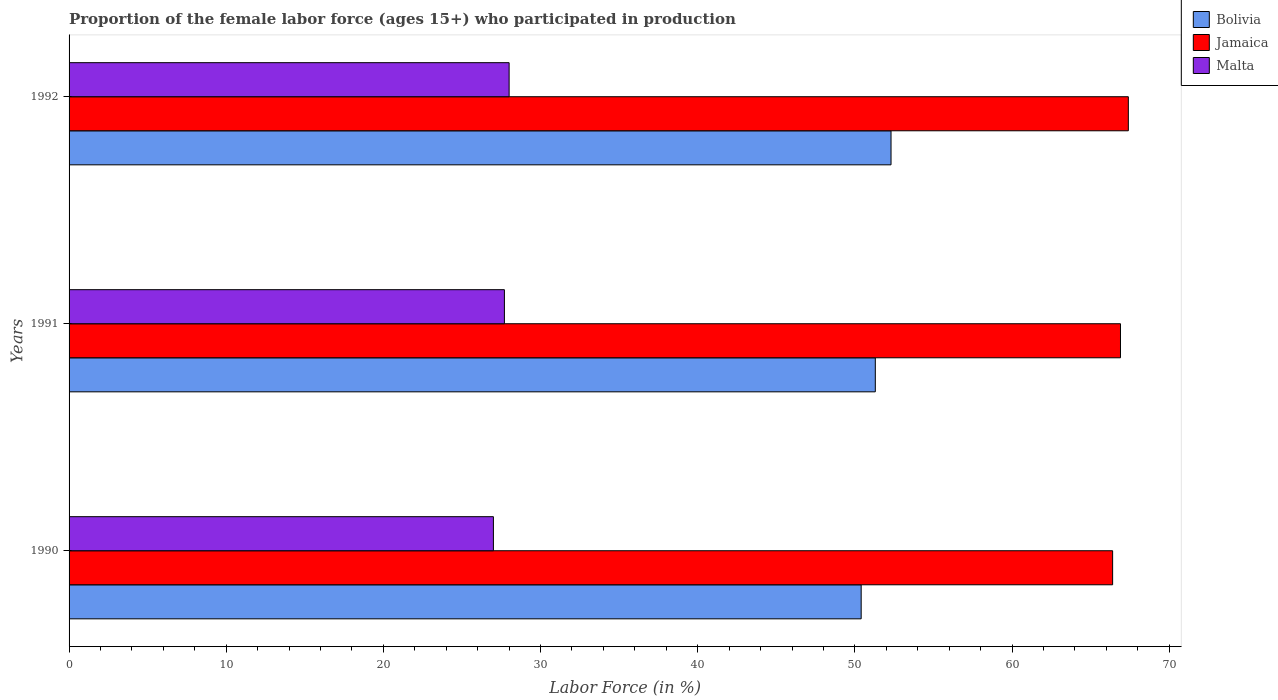How many different coloured bars are there?
Provide a succinct answer. 3. Are the number of bars on each tick of the Y-axis equal?
Offer a terse response. Yes. What is the proportion of the female labor force who participated in production in Jamaica in 1991?
Your answer should be compact. 66.9. Across all years, what is the maximum proportion of the female labor force who participated in production in Jamaica?
Your answer should be very brief. 67.4. Across all years, what is the minimum proportion of the female labor force who participated in production in Jamaica?
Provide a short and direct response. 66.4. In which year was the proportion of the female labor force who participated in production in Jamaica maximum?
Your response must be concise. 1992. What is the total proportion of the female labor force who participated in production in Bolivia in the graph?
Your response must be concise. 154. What is the difference between the proportion of the female labor force who participated in production in Bolivia in 1992 and the proportion of the female labor force who participated in production in Jamaica in 1991?
Offer a very short reply. -14.6. What is the average proportion of the female labor force who participated in production in Malta per year?
Make the answer very short. 27.57. In the year 1990, what is the difference between the proportion of the female labor force who participated in production in Bolivia and proportion of the female labor force who participated in production in Malta?
Offer a terse response. 23.4. In how many years, is the proportion of the female labor force who participated in production in Malta greater than 2 %?
Provide a short and direct response. 3. What is the ratio of the proportion of the female labor force who participated in production in Malta in 1990 to that in 1992?
Your response must be concise. 0.96. Is the proportion of the female labor force who participated in production in Malta in 1990 less than that in 1992?
Offer a terse response. Yes. What is the difference between the highest and the second highest proportion of the female labor force who participated in production in Malta?
Give a very brief answer. 0.3. What is the difference between the highest and the lowest proportion of the female labor force who participated in production in Bolivia?
Your answer should be very brief. 1.9. In how many years, is the proportion of the female labor force who participated in production in Malta greater than the average proportion of the female labor force who participated in production in Malta taken over all years?
Keep it short and to the point. 2. Is the sum of the proportion of the female labor force who participated in production in Bolivia in 1990 and 1992 greater than the maximum proportion of the female labor force who participated in production in Malta across all years?
Ensure brevity in your answer.  Yes. What does the 2nd bar from the top in 1992 represents?
Your response must be concise. Jamaica. What does the 2nd bar from the bottom in 1992 represents?
Ensure brevity in your answer.  Jamaica. Is it the case that in every year, the sum of the proportion of the female labor force who participated in production in Bolivia and proportion of the female labor force who participated in production in Jamaica is greater than the proportion of the female labor force who participated in production in Malta?
Make the answer very short. Yes. How many bars are there?
Ensure brevity in your answer.  9. Are all the bars in the graph horizontal?
Keep it short and to the point. Yes. What is the difference between two consecutive major ticks on the X-axis?
Your response must be concise. 10. Are the values on the major ticks of X-axis written in scientific E-notation?
Provide a succinct answer. No. Does the graph contain any zero values?
Your answer should be very brief. No. Does the graph contain grids?
Your answer should be very brief. No. How many legend labels are there?
Your response must be concise. 3. What is the title of the graph?
Your answer should be very brief. Proportion of the female labor force (ages 15+) who participated in production. What is the Labor Force (in %) in Bolivia in 1990?
Ensure brevity in your answer.  50.4. What is the Labor Force (in %) in Jamaica in 1990?
Provide a succinct answer. 66.4. What is the Labor Force (in %) in Bolivia in 1991?
Your answer should be very brief. 51.3. What is the Labor Force (in %) in Jamaica in 1991?
Offer a terse response. 66.9. What is the Labor Force (in %) in Malta in 1991?
Provide a succinct answer. 27.7. What is the Labor Force (in %) in Bolivia in 1992?
Keep it short and to the point. 52.3. What is the Labor Force (in %) in Jamaica in 1992?
Keep it short and to the point. 67.4. Across all years, what is the maximum Labor Force (in %) of Bolivia?
Keep it short and to the point. 52.3. Across all years, what is the maximum Labor Force (in %) of Jamaica?
Your response must be concise. 67.4. Across all years, what is the maximum Labor Force (in %) in Malta?
Provide a succinct answer. 28. Across all years, what is the minimum Labor Force (in %) in Bolivia?
Offer a very short reply. 50.4. Across all years, what is the minimum Labor Force (in %) of Jamaica?
Provide a succinct answer. 66.4. What is the total Labor Force (in %) in Bolivia in the graph?
Your response must be concise. 154. What is the total Labor Force (in %) of Jamaica in the graph?
Give a very brief answer. 200.7. What is the total Labor Force (in %) of Malta in the graph?
Provide a succinct answer. 82.7. What is the difference between the Labor Force (in %) of Bolivia in 1990 and that in 1991?
Your answer should be compact. -0.9. What is the difference between the Labor Force (in %) in Malta in 1990 and that in 1991?
Give a very brief answer. -0.7. What is the difference between the Labor Force (in %) of Jamaica in 1990 and that in 1992?
Your answer should be compact. -1. What is the difference between the Labor Force (in %) of Malta in 1990 and that in 1992?
Your answer should be very brief. -1. What is the difference between the Labor Force (in %) of Bolivia in 1991 and that in 1992?
Offer a very short reply. -1. What is the difference between the Labor Force (in %) of Malta in 1991 and that in 1992?
Your answer should be compact. -0.3. What is the difference between the Labor Force (in %) of Bolivia in 1990 and the Labor Force (in %) of Jamaica in 1991?
Keep it short and to the point. -16.5. What is the difference between the Labor Force (in %) of Bolivia in 1990 and the Labor Force (in %) of Malta in 1991?
Offer a terse response. 22.7. What is the difference between the Labor Force (in %) of Jamaica in 1990 and the Labor Force (in %) of Malta in 1991?
Ensure brevity in your answer.  38.7. What is the difference between the Labor Force (in %) in Bolivia in 1990 and the Labor Force (in %) in Jamaica in 1992?
Your answer should be very brief. -17. What is the difference between the Labor Force (in %) of Bolivia in 1990 and the Labor Force (in %) of Malta in 1992?
Your answer should be very brief. 22.4. What is the difference between the Labor Force (in %) in Jamaica in 1990 and the Labor Force (in %) in Malta in 1992?
Make the answer very short. 38.4. What is the difference between the Labor Force (in %) in Bolivia in 1991 and the Labor Force (in %) in Jamaica in 1992?
Your answer should be compact. -16.1. What is the difference between the Labor Force (in %) of Bolivia in 1991 and the Labor Force (in %) of Malta in 1992?
Keep it short and to the point. 23.3. What is the difference between the Labor Force (in %) in Jamaica in 1991 and the Labor Force (in %) in Malta in 1992?
Your answer should be compact. 38.9. What is the average Labor Force (in %) of Bolivia per year?
Your response must be concise. 51.33. What is the average Labor Force (in %) in Jamaica per year?
Provide a succinct answer. 66.9. What is the average Labor Force (in %) of Malta per year?
Offer a terse response. 27.57. In the year 1990, what is the difference between the Labor Force (in %) of Bolivia and Labor Force (in %) of Jamaica?
Offer a terse response. -16. In the year 1990, what is the difference between the Labor Force (in %) in Bolivia and Labor Force (in %) in Malta?
Provide a succinct answer. 23.4. In the year 1990, what is the difference between the Labor Force (in %) of Jamaica and Labor Force (in %) of Malta?
Your answer should be very brief. 39.4. In the year 1991, what is the difference between the Labor Force (in %) in Bolivia and Labor Force (in %) in Jamaica?
Offer a very short reply. -15.6. In the year 1991, what is the difference between the Labor Force (in %) of Bolivia and Labor Force (in %) of Malta?
Keep it short and to the point. 23.6. In the year 1991, what is the difference between the Labor Force (in %) of Jamaica and Labor Force (in %) of Malta?
Offer a terse response. 39.2. In the year 1992, what is the difference between the Labor Force (in %) in Bolivia and Labor Force (in %) in Jamaica?
Offer a very short reply. -15.1. In the year 1992, what is the difference between the Labor Force (in %) in Bolivia and Labor Force (in %) in Malta?
Your response must be concise. 24.3. In the year 1992, what is the difference between the Labor Force (in %) of Jamaica and Labor Force (in %) of Malta?
Your response must be concise. 39.4. What is the ratio of the Labor Force (in %) in Bolivia in 1990 to that in 1991?
Provide a short and direct response. 0.98. What is the ratio of the Labor Force (in %) in Malta in 1990 to that in 1991?
Your answer should be compact. 0.97. What is the ratio of the Labor Force (in %) of Bolivia in 1990 to that in 1992?
Offer a terse response. 0.96. What is the ratio of the Labor Force (in %) of Jamaica in 1990 to that in 1992?
Your answer should be very brief. 0.99. What is the ratio of the Labor Force (in %) in Bolivia in 1991 to that in 1992?
Your answer should be very brief. 0.98. What is the ratio of the Labor Force (in %) of Malta in 1991 to that in 1992?
Provide a succinct answer. 0.99. What is the difference between the highest and the second highest Labor Force (in %) of Jamaica?
Your answer should be very brief. 0.5. What is the difference between the highest and the second highest Labor Force (in %) in Malta?
Give a very brief answer. 0.3. What is the difference between the highest and the lowest Labor Force (in %) in Jamaica?
Your answer should be very brief. 1. What is the difference between the highest and the lowest Labor Force (in %) in Malta?
Offer a very short reply. 1. 